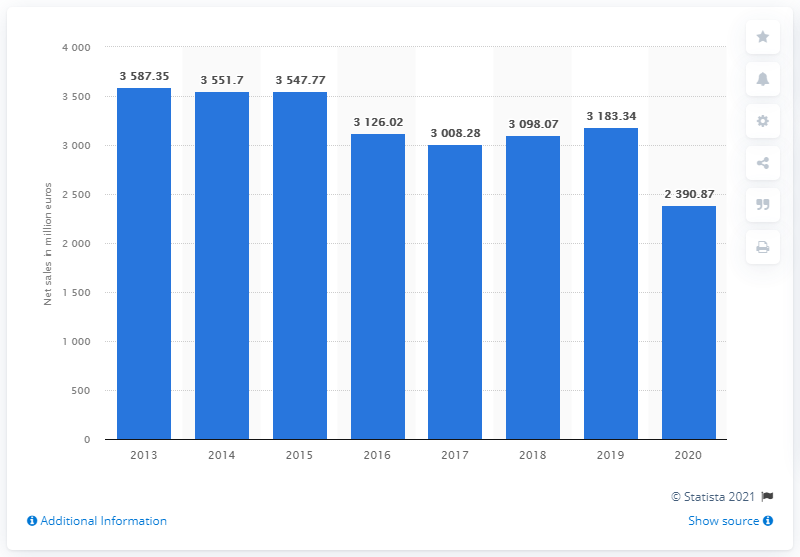Draw attention to some important aspects in this diagram. In 2020, Prada's global net sales were 2390.87. 